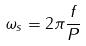Convert formula to latex. <formula><loc_0><loc_0><loc_500><loc_500>\omega _ { s } = 2 \pi \frac { f } { P }</formula> 